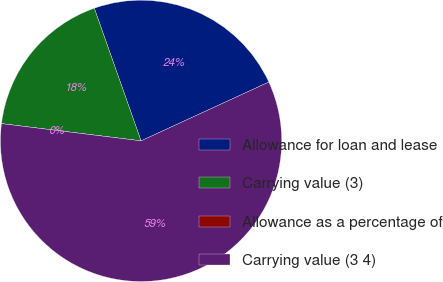Convert chart to OTSL. <chart><loc_0><loc_0><loc_500><loc_500><pie_chart><fcel>Allowance for loan and lease<fcel>Carrying value (3)<fcel>Allowance as a percentage of<fcel>Carrying value (3 4)<nl><fcel>23.53%<fcel>17.65%<fcel>0.0%<fcel>58.82%<nl></chart> 